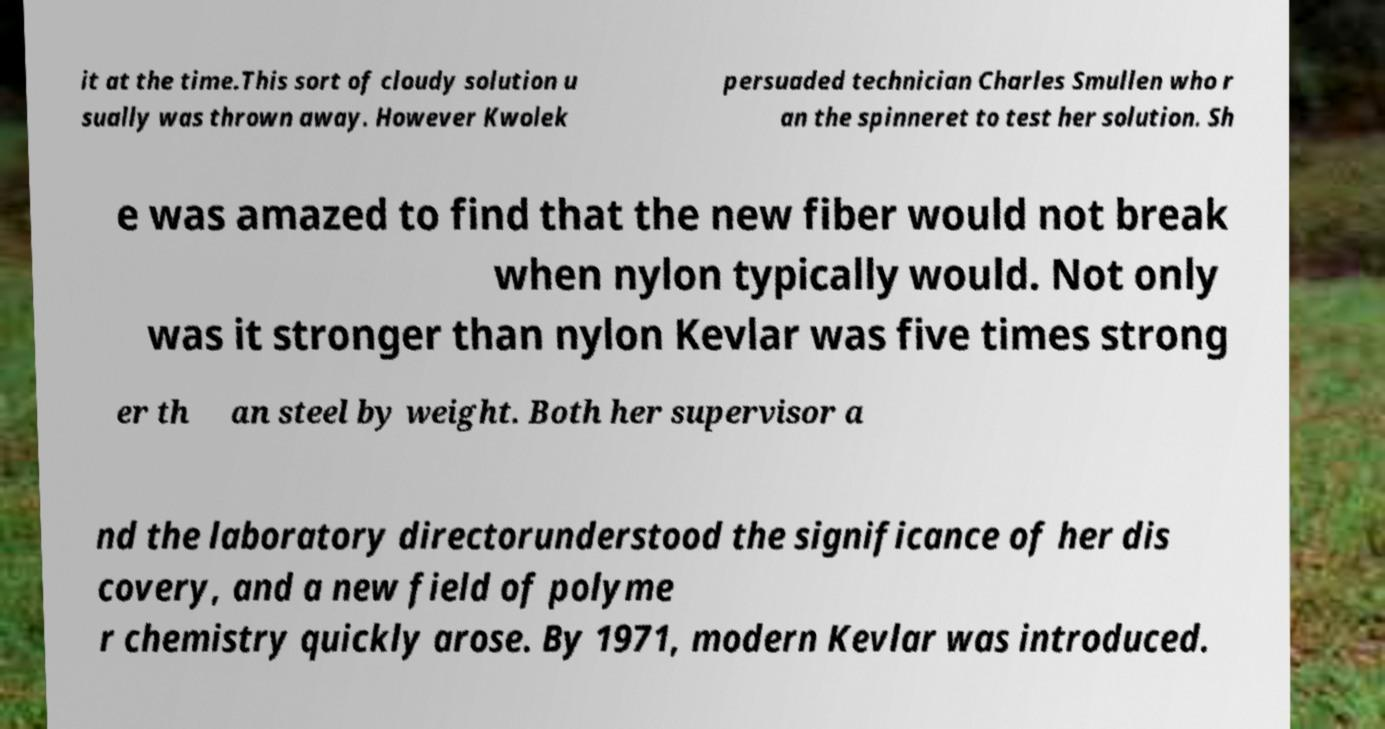Can you read and provide the text displayed in the image?This photo seems to have some interesting text. Can you extract and type it out for me? it at the time.This sort of cloudy solution u sually was thrown away. However Kwolek persuaded technician Charles Smullen who r an the spinneret to test her solution. Sh e was amazed to find that the new fiber would not break when nylon typically would. Not only was it stronger than nylon Kevlar was five times strong er th an steel by weight. Both her supervisor a nd the laboratory directorunderstood the significance of her dis covery, and a new field of polyme r chemistry quickly arose. By 1971, modern Kevlar was introduced. 